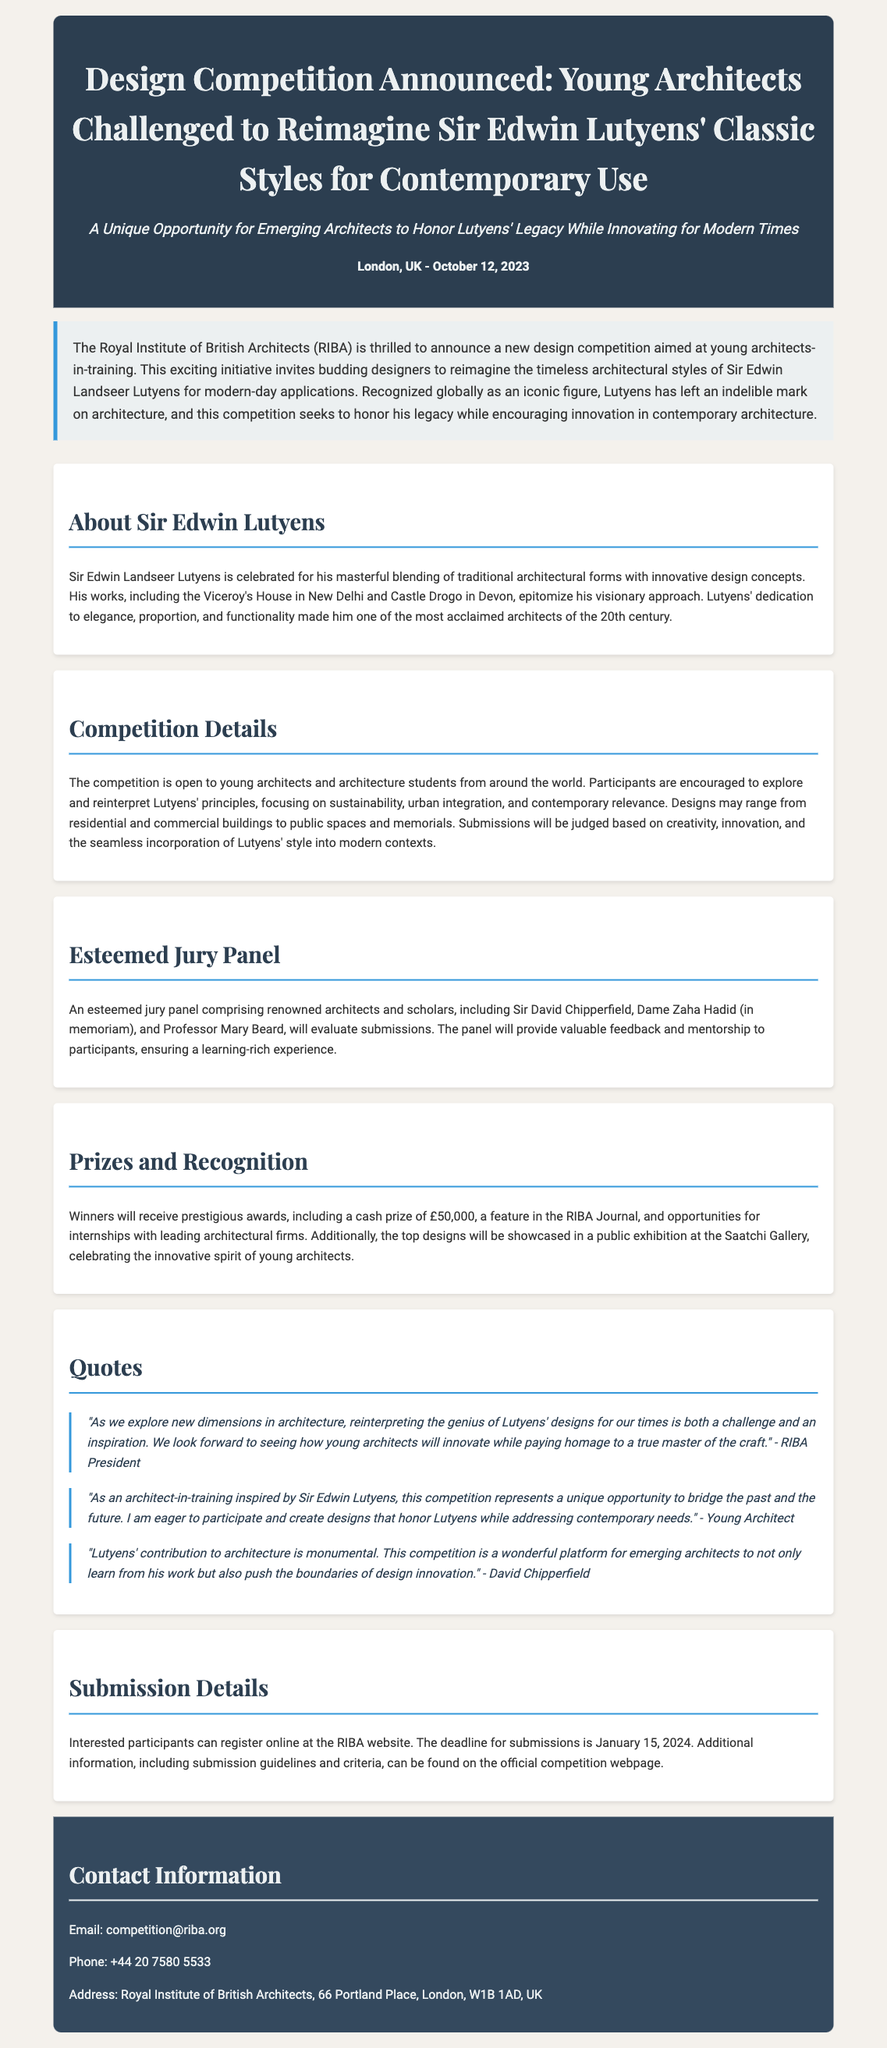what is the title of the design competition? The title is stated in the header section of the document, which mentions the design competition aimed at young architects.
Answer: Design Competition Announced: Young Architects Challenged to Reimagine Sir Edwin Lutyens' Classic Styles for Contemporary Use who is organizing the competition? The document mentions the organization responsible for the competition in the introductory paragraph.
Answer: Royal Institute of British Architects (RIBA) what is the cash prize for the winners? The cash prize amount is specified under the Prizes and Recognition section of the document.
Answer: £50,000 when is the deadline for submissions? The deadline for submissions is mentioned in the Submission Details section of the document.
Answer: January 15, 2024 who are some members of the jury panel? The document lists notable members of the jury panel in the respective section, providing examples of renowned architects.
Answer: Sir David Chipperfield, Dame Zaha Hadid (in memoriam), Professor Mary Beard what is one focus area for participants' designs? The focus areas for participants are provided in the Competition Details section, stating key aspects to consider.
Answer: sustainability why is this competition considered a unique opportunity? The document describes the competition's significance in bridging past and future while honoring Lutyens' legacy.
Answer: Bridge the past and the future how will the top designs be recognized? The document outlines how the top designs will be recognized and showcased, highlighting the exhibition venue.
Answer: Showcase in a public exhibition at the Saatchi Gallery 